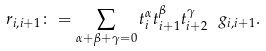Convert formula to latex. <formula><loc_0><loc_0><loc_500><loc_500>r _ { i , i + 1 } \colon = \sum _ { \alpha + \beta + \gamma = 0 } t _ { i } ^ { \alpha } t _ { i + 1 } ^ { \beta } t _ { i + 2 } ^ { \gamma } \ g _ { i , i + 1 } .</formula> 